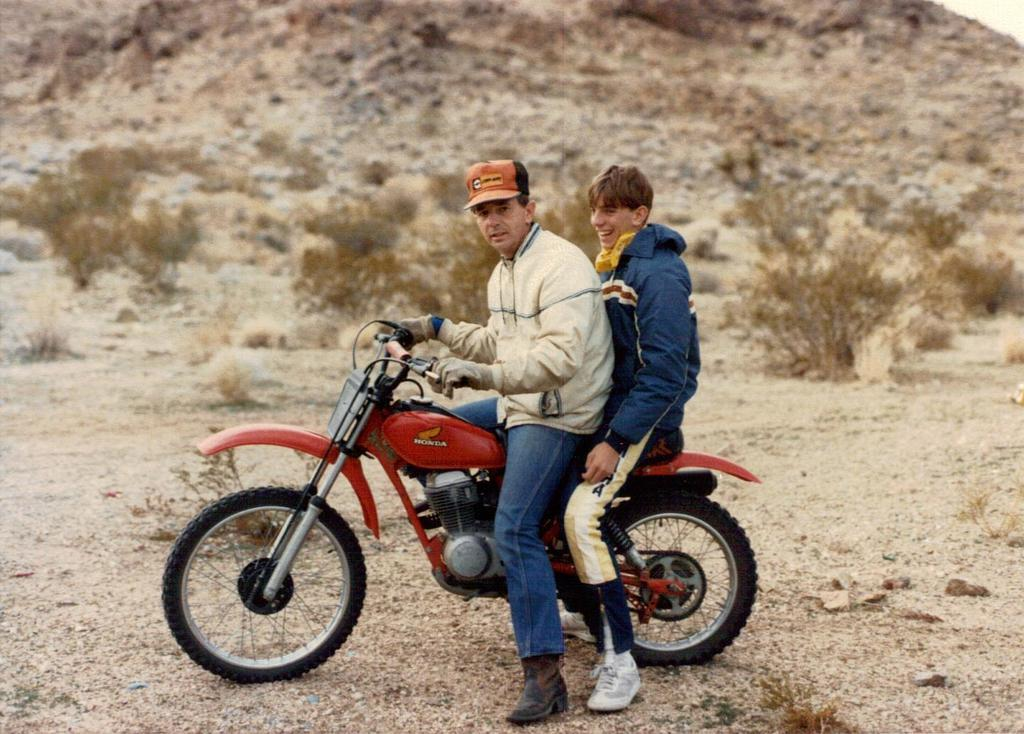How many people are in the image? There are two persons in the image. What are the persons doing in the image? The persons are sitting on a motorbike. What type of clothing are the persons wearing? The persons are wearing jackets. What can be seen in the background of the image? There are plants visible in the image. What is the facial expression of one of the men? One of the men is smiling. What accessory is worn by one of the men? One of the men is wearing a cap. What is the man wearing a cap doing with his hand? The man wearing a cap is holding the handle of the motorbike. What type of wool is being spun by the man wearing a cap in the image? There is no wool or spinning activity present in the image. Can you tell me the name of the guide who is leading the tour in the image? There is no guide or tour present in the image. 